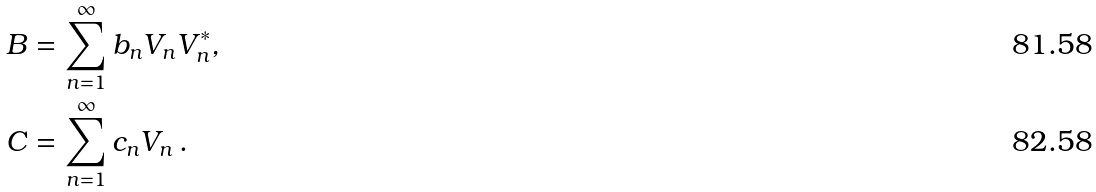Convert formula to latex. <formula><loc_0><loc_0><loc_500><loc_500>B & = \sum _ { n = 1 } ^ { \infty } b _ { n } V _ { n } V _ { n } ^ { * } , \\ C & = \sum _ { n = 1 } ^ { \infty } c _ { n } V _ { n } \, .</formula> 